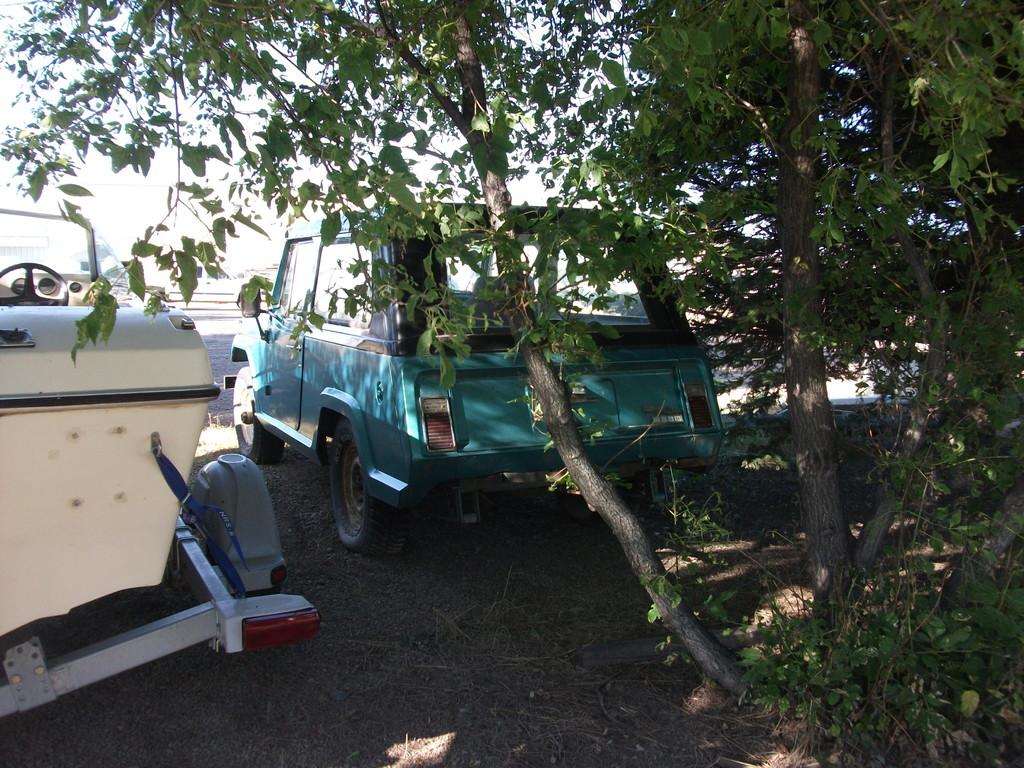What types of objects are on the ground in the image? There are vehicles on the ground in the image. What type of natural vegetation can be seen in the image? There are trees visible in the image. What is visible in the background of the image? The sky is visible in the background of the image. What type of suit is hanging from the tree in the image? There is no suit present in the image; it features vehicles on the ground, trees, and the sky. How many dimes can be seen scattered on the ground in the image? There are no dimes visible in the image; it only shows vehicles on the ground, trees, and the sky. 